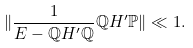Convert formula to latex. <formula><loc_0><loc_0><loc_500><loc_500>\| \frac { 1 } { E - \mathbb { Q } H ^ { \prime } \mathbb { Q } } \mathbb { Q } H ^ { \prime } \mathbb { P } \| \ll 1 .</formula> 